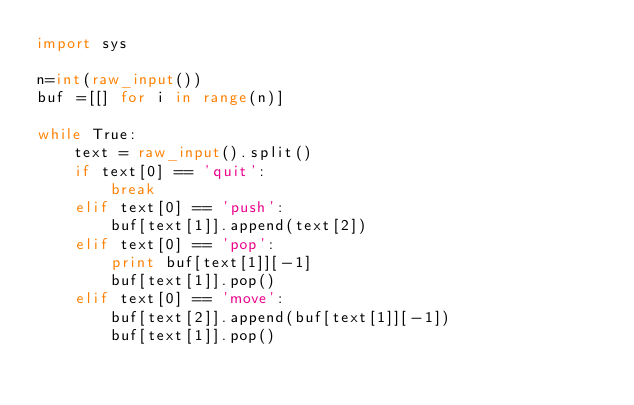<code> <loc_0><loc_0><loc_500><loc_500><_Python_>import sys

n=int(raw_input())
buf =[[] for i in range(n)]

while True:
    text = raw_input().split()
    if text[0] == 'quit':
        break
    elif text[0] == 'push':
        buf[text[1]].append(text[2])
    elif text[0] == 'pop':
        print buf[text[1]][-1]
        buf[text[1]].pop()
    elif text[0] == 'move':
        buf[text[2]].append(buf[text[1]][-1])
        buf[text[1]].pop()</code> 